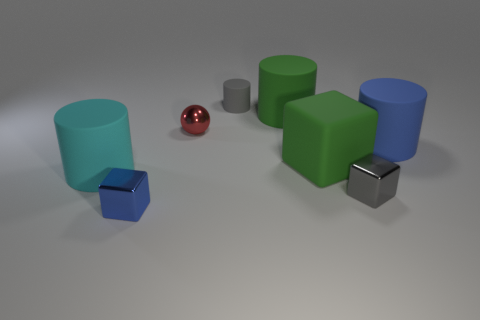Subtract all brown cylinders. Subtract all brown cubes. How many cylinders are left? 4 Add 1 small yellow shiny objects. How many objects exist? 9 Subtract all spheres. How many objects are left? 7 Add 8 small blocks. How many small blocks are left? 10 Add 6 green matte cylinders. How many green matte cylinders exist? 7 Subtract 1 red balls. How many objects are left? 7 Subtract all small red metal spheres. Subtract all tiny yellow balls. How many objects are left? 7 